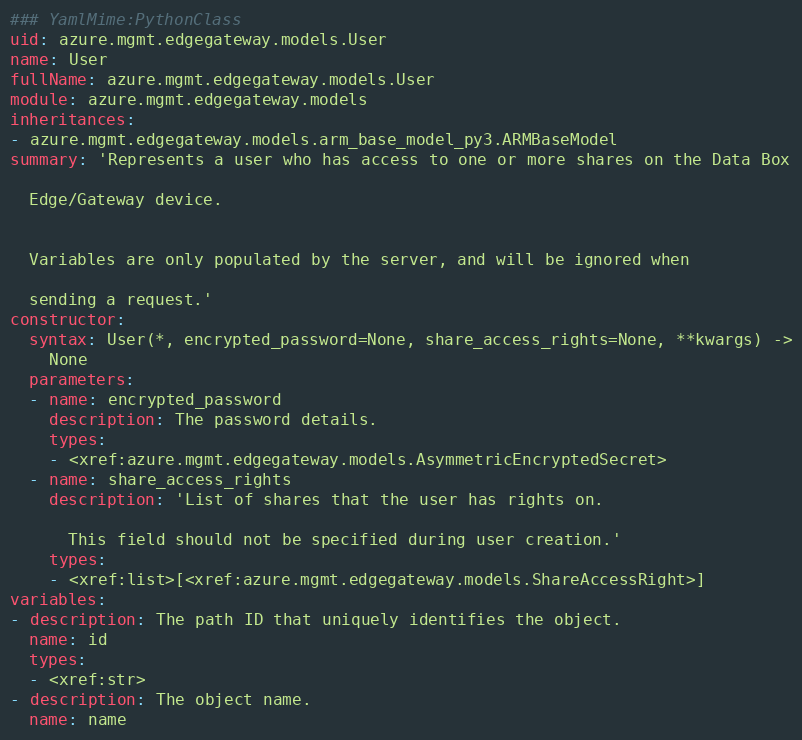Convert code to text. <code><loc_0><loc_0><loc_500><loc_500><_YAML_>### YamlMime:PythonClass
uid: azure.mgmt.edgegateway.models.User
name: User
fullName: azure.mgmt.edgegateway.models.User
module: azure.mgmt.edgegateway.models
inheritances:
- azure.mgmt.edgegateway.models.arm_base_model_py3.ARMBaseModel
summary: 'Represents a user who has access to one or more shares on the Data Box

  Edge/Gateway device.


  Variables are only populated by the server, and will be ignored when

  sending a request.'
constructor:
  syntax: User(*, encrypted_password=None, share_access_rights=None, **kwargs) ->
    None
  parameters:
  - name: encrypted_password
    description: The password details.
    types:
    - <xref:azure.mgmt.edgegateway.models.AsymmetricEncryptedSecret>
  - name: share_access_rights
    description: 'List of shares that the user has rights on.

      This field should not be specified during user creation.'
    types:
    - <xref:list>[<xref:azure.mgmt.edgegateway.models.ShareAccessRight>]
variables:
- description: The path ID that uniquely identifies the object.
  name: id
  types:
  - <xref:str>
- description: The object name.
  name: name</code> 